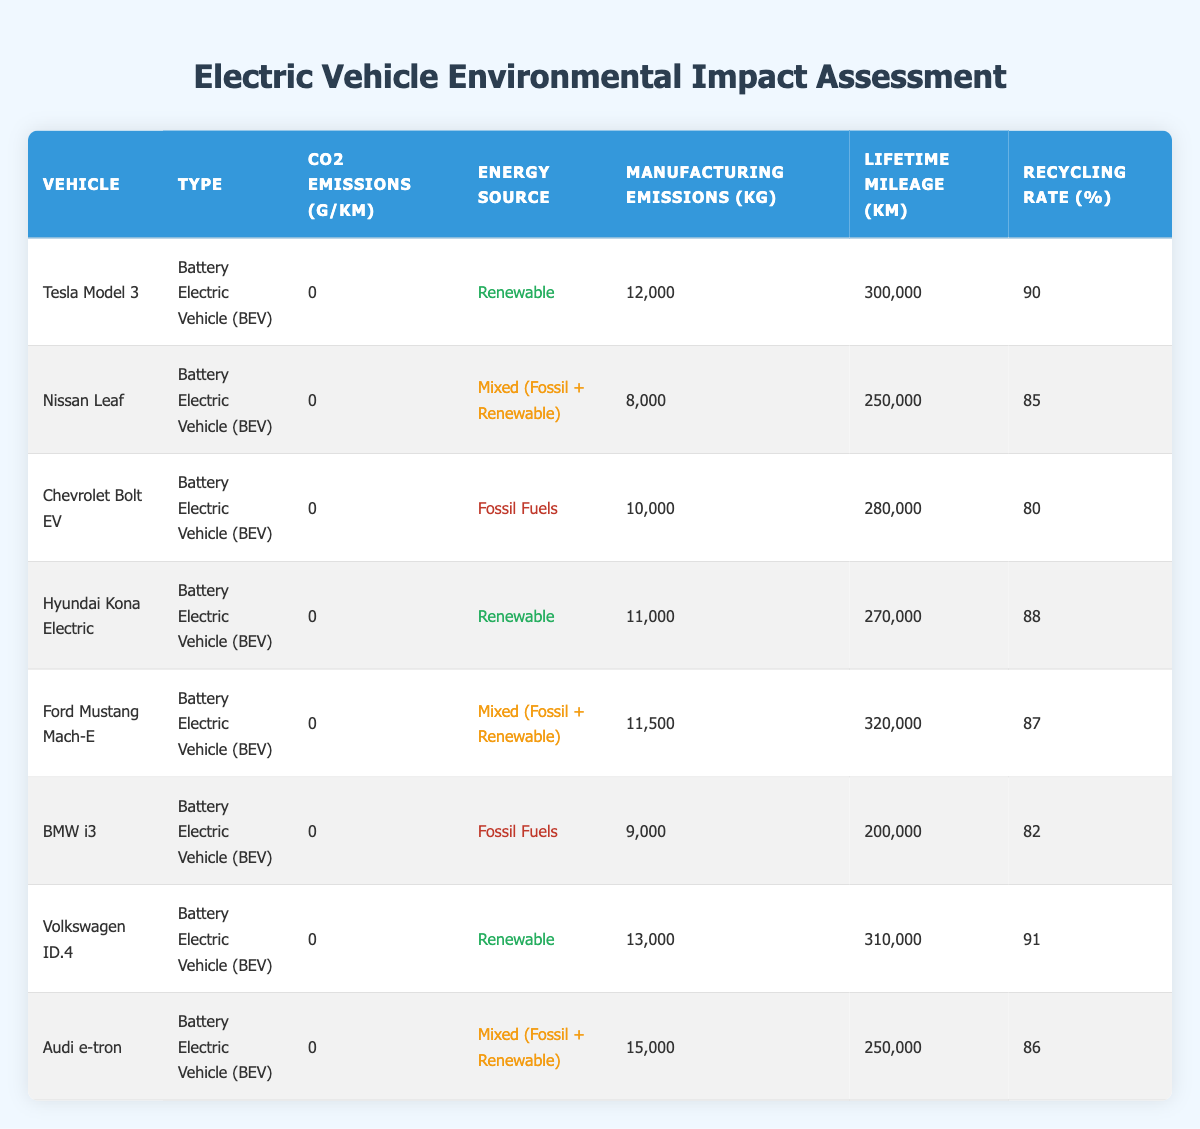What is the CO2 emission of the Tesla Model 3? From the table, I can find that the CO2 emissions for the Tesla Model 3 are listed in the "CO2 Emissions (g/km)" column. It shows a value of 0 g/km.
Answer: 0 g/km Which vehicle has the highest manufacturing emissions? By looking at the "Manufacturing Emissions (kg)" column, I can see the values for each vehicle. The Audi e-tron has the highest value at 15,000 kg.
Answer: Audi e-tron What is the average recycling rate of vehicles powered by renewable energy? First, I need to identify the vehicles with renewable energy sources from the "Energy Source" column. These vehicles are the Tesla Model 3, Hyundai Kona Electric, and Volkswagen ID.4. Their recycling rates are 90%, 88%, and 91% respectively. I will sum these values: 90 + 88 + 91 = 269. Then, I divide by the number of vehicles: 269/3 = 89.67.
Answer: 89.67% Is the Nissan Leaf classified as a Battery Electric Vehicle? The table lists the Nissan Leaf's type as "Battery Electric Vehicle (BEV)." Therefore, it is true that the Nissan Leaf is classified as a BEV.
Answer: Yes What percentage of the Chevrolet Bolt EV's lifetime mileage is less than that of the Ford Mustang Mach-E? The lifetime mileage of the Chevrolet Bolt EV is 280,000 km, while that of the Ford Mustang Mach-E is 320,000 km. To find the percentage, I can use the formula: (280,000/320,000) * 100 = 87.5%.
Answer: 87.5% Which vehicles have a recycling rate of over 89%? I need to check the "Recycling Rate (%)" column for all vehicles and filter them to find which have a recycling rate greater than 89%. The vehicles that fit this criterion are the Volkswagen ID.4 (91%) and Tesla Model 3 (90%).
Answer: Volkswagen ID.4, Tesla Model 3 What is the total manufacturing emissions of all vehicles? I will sum the manufacturing emissions for all vehicles listed in the table, which are 12,000 kg (Tesla Model 3) + 8,000 kg (Nissan Leaf) + 10,000 kg (Chevrolet Bolt EV) + 11,000 kg (Hyundai Kona Electric) + 11,500 kg (Ford Mustang Mach-E) + 9,000 kg (BMW i3) + 13,000 kg (Volkswagen ID.4) + 15,000 kg (Audi e-tron). The total is 12,000 + 8,000 + 10,000 + 11,000 + 11,500 + 9,000 + 13,000 + 15,000 = 99,500 kg.
Answer: 99,500 kg How many vehicles use fossil fuels as their energy source? I can find this information by checking the "Energy Source" column. The Chevrolet Bolt EV and BMW i3 are both listed as using fossil fuels. Therefore, the total number of vehicles using fossil fuels is 2.
Answer: 2 